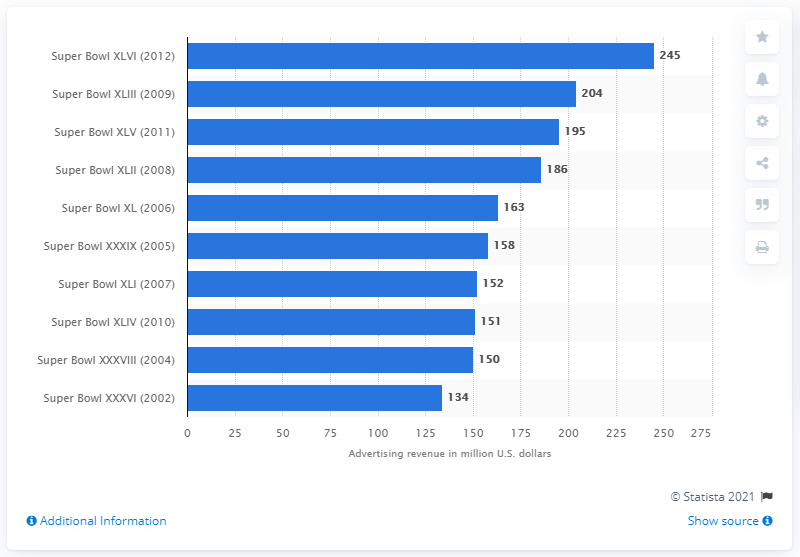Give some essential details in this illustration. The total ad revenue of Super Bowl XLVI was 245. 